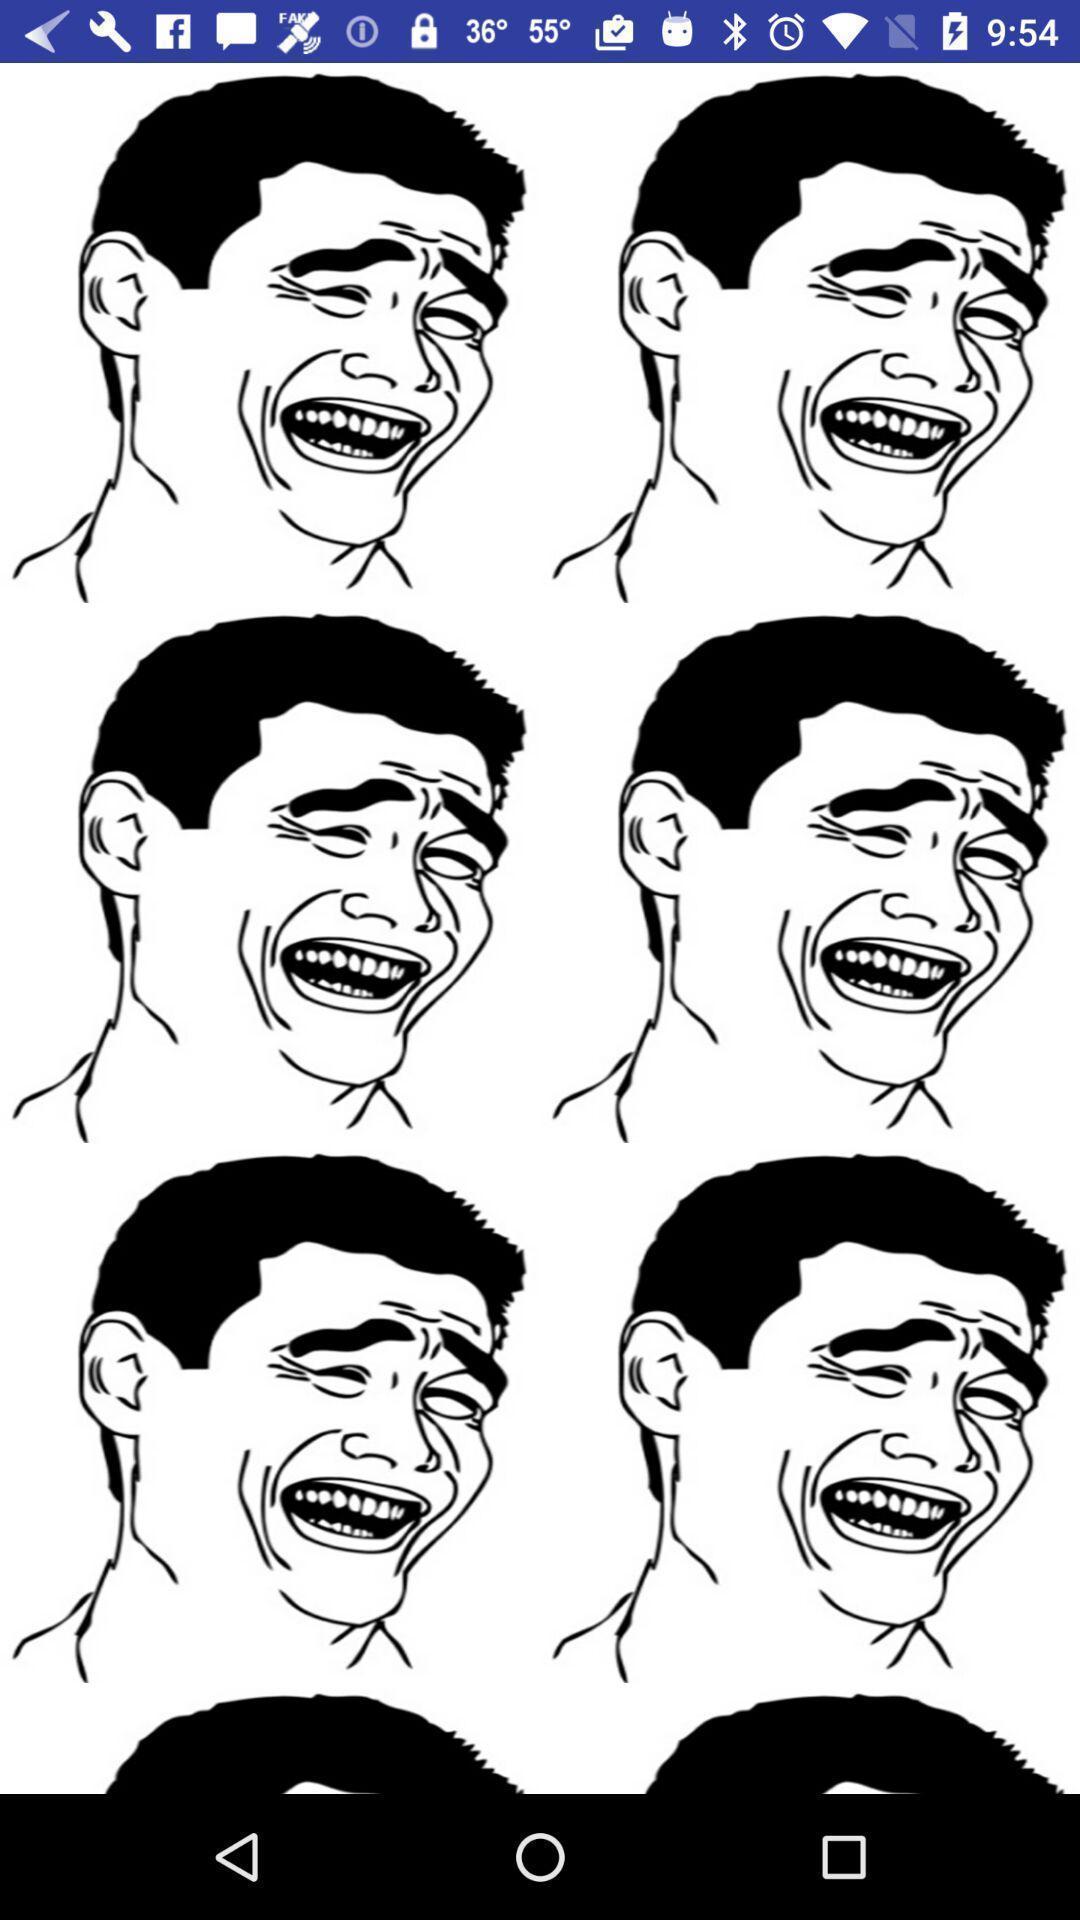Provide a textual representation of this image. Screen display various art images. 